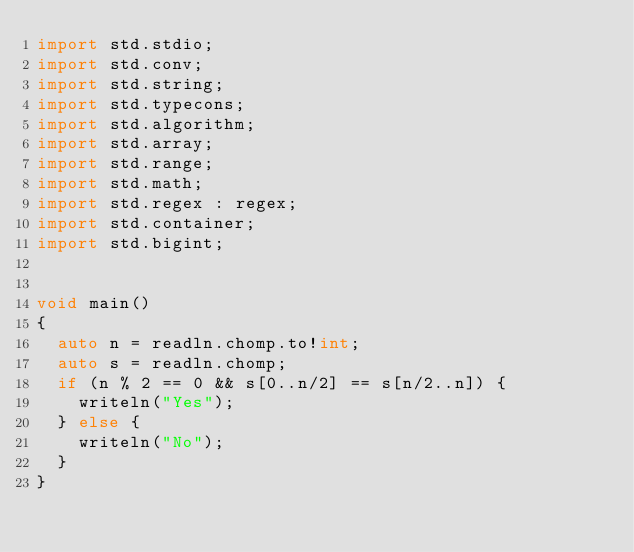Convert code to text. <code><loc_0><loc_0><loc_500><loc_500><_D_>import std.stdio;
import std.conv;
import std.string;
import std.typecons;
import std.algorithm;
import std.array;
import std.range;
import std.math;
import std.regex : regex;
import std.container;
import std.bigint;


void main()
{
  auto n = readln.chomp.to!int;
  auto s = readln.chomp;
  if (n % 2 == 0 && s[0..n/2] == s[n/2..n]) {
    writeln("Yes");
  } else {
    writeln("No");
  }
}
</code> 